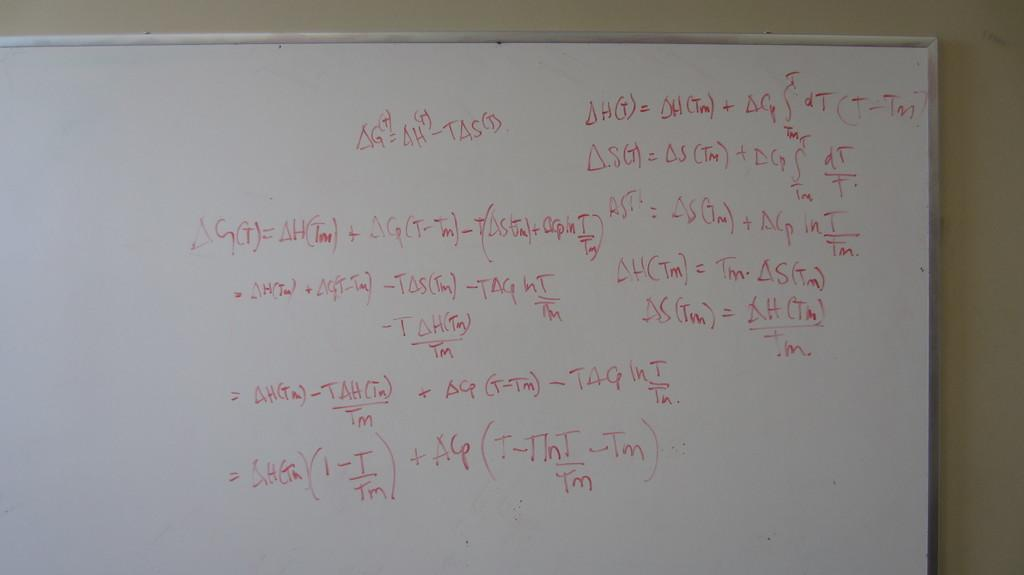<image>
Summarize the visual content of the image. A whiteboard scrawled upon with writing periodically finds a Tm symbol. 